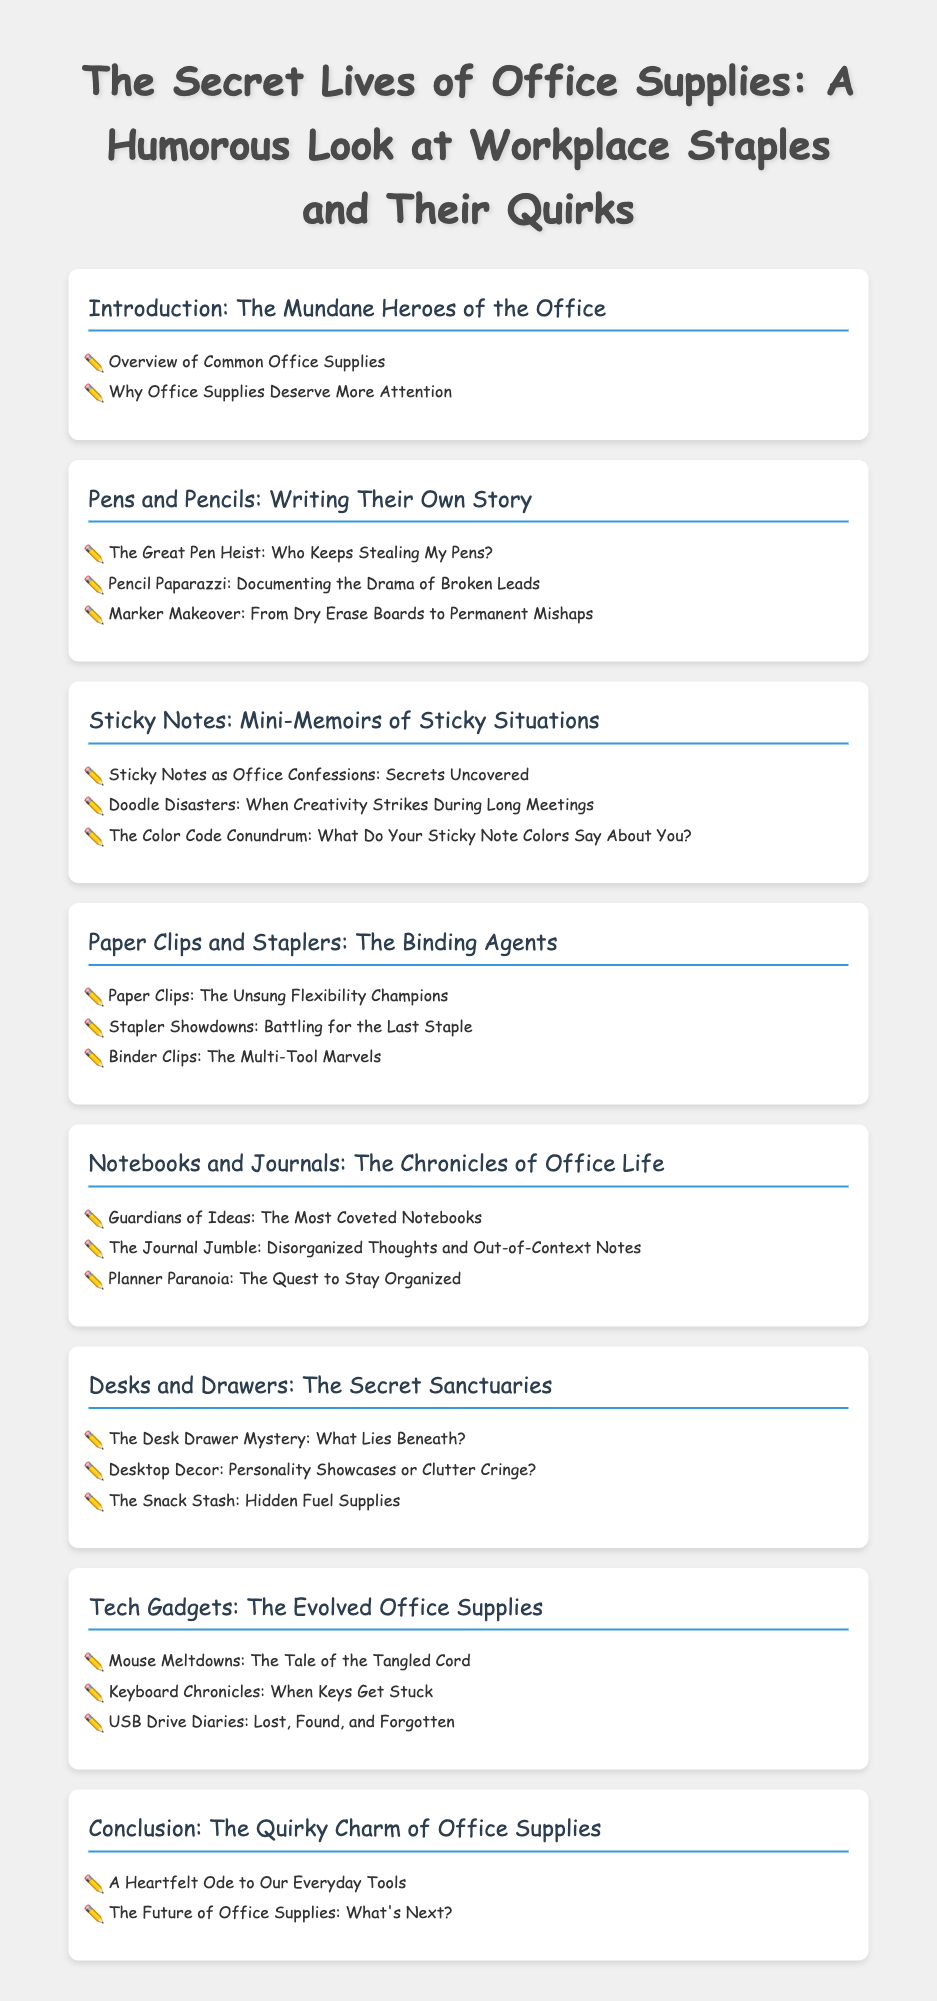what is the title of the book? The title is presented prominently at the top of the document, showcasing the main theme of the content.
Answer: The Secret Lives of Office Supplies: A Humorous Look at Workplace Staples and Their Quirks how many chapters are in the Table of Contents? By counting the listed chapters, we find the total number of chapters presented in the document.
Answer: Seven what chapter follows "Pens and Pencils: Writing Their Own Story"? The order of the chapters is sequentially listed, providing a clear flow from one chapter to the next.
Answer: Sticky Notes: Mini-Memoirs of Sticky Situations what is the first section under "Desks and Drawers: The Secret Sanctuaries"? The sections listed under each chapter indicate specific focuses within the subject of that chapter.
Answer: The Desk Drawer Mystery: What Lies Beneath? which chapter features "Mouse Meltdowns"? The sections within the chapters relate to the broader topic of office supplies, helping to identify where specific themes are discussed.
Answer: Tech Gadgets: The Evolved Office Supplies how many sections are in the chapter "Notebooks and Journals: The Chronicles of Office Life"? The section items listed provide the count of specific discussions or themes under this chapter.
Answer: Three what is the final section in the conclusion chapter? The sections arranged at the end of each chapter summarize key thoughts and final remarks related to that chapter's theme.
Answer: The Future of Office Supplies: What's Next? 